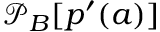Convert formula to latex. <formula><loc_0><loc_0><loc_500><loc_500>\mathcal { P } _ { B } [ p ^ { \prime } ( a ) ]</formula> 